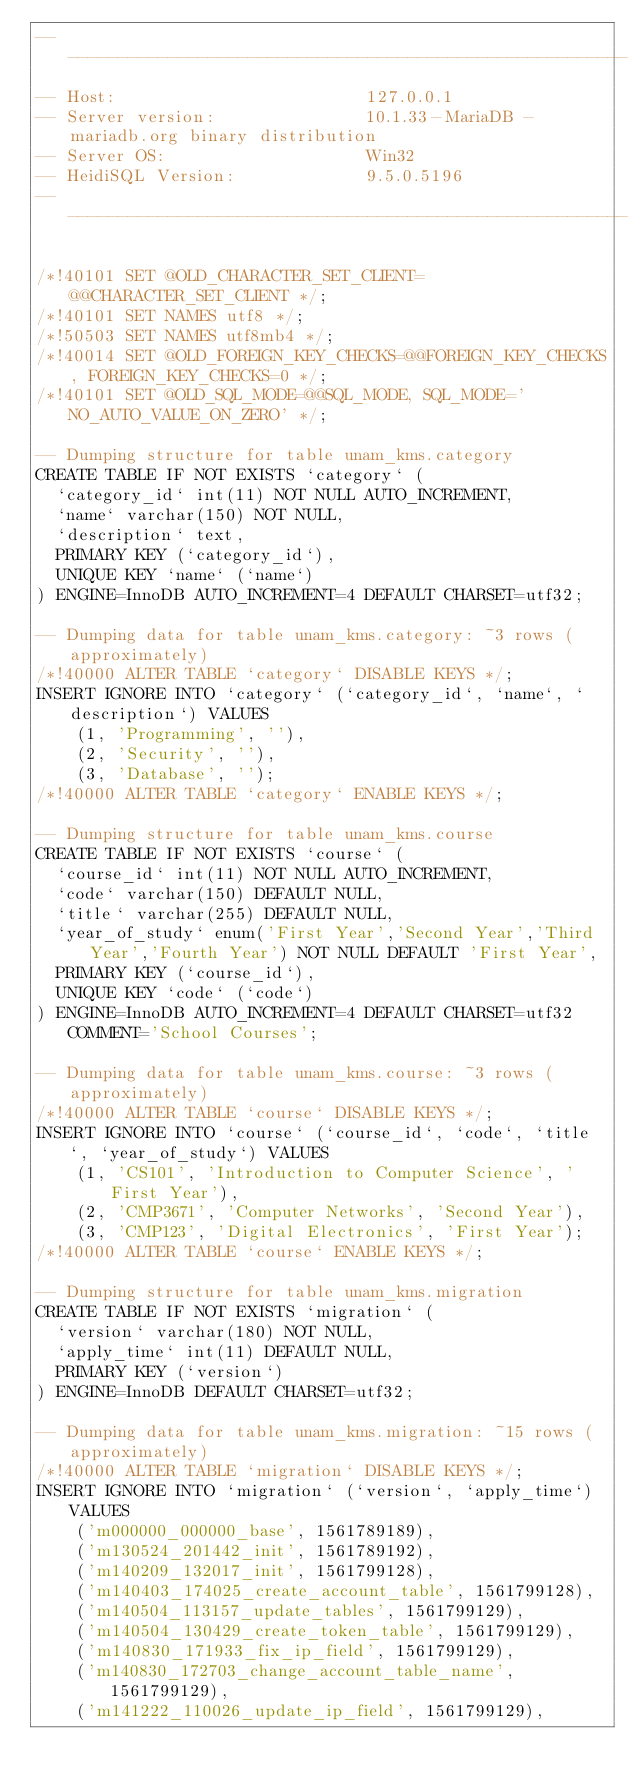Convert code to text. <code><loc_0><loc_0><loc_500><loc_500><_SQL_>-- --------------------------------------------------------
-- Host:                         127.0.0.1
-- Server version:               10.1.33-MariaDB - mariadb.org binary distribution
-- Server OS:                    Win32
-- HeidiSQL Version:             9.5.0.5196
-- --------------------------------------------------------

/*!40101 SET @OLD_CHARACTER_SET_CLIENT=@@CHARACTER_SET_CLIENT */;
/*!40101 SET NAMES utf8 */;
/*!50503 SET NAMES utf8mb4 */;
/*!40014 SET @OLD_FOREIGN_KEY_CHECKS=@@FOREIGN_KEY_CHECKS, FOREIGN_KEY_CHECKS=0 */;
/*!40101 SET @OLD_SQL_MODE=@@SQL_MODE, SQL_MODE='NO_AUTO_VALUE_ON_ZERO' */;

-- Dumping structure for table unam_kms.category
CREATE TABLE IF NOT EXISTS `category` (
  `category_id` int(11) NOT NULL AUTO_INCREMENT,
  `name` varchar(150) NOT NULL,
  `description` text,
  PRIMARY KEY (`category_id`),
  UNIQUE KEY `name` (`name`)
) ENGINE=InnoDB AUTO_INCREMENT=4 DEFAULT CHARSET=utf32;

-- Dumping data for table unam_kms.category: ~3 rows (approximately)
/*!40000 ALTER TABLE `category` DISABLE KEYS */;
INSERT IGNORE INTO `category` (`category_id`, `name`, `description`) VALUES
	(1, 'Programming', ''),
	(2, 'Security', ''),
	(3, 'Database', '');
/*!40000 ALTER TABLE `category` ENABLE KEYS */;

-- Dumping structure for table unam_kms.course
CREATE TABLE IF NOT EXISTS `course` (
  `course_id` int(11) NOT NULL AUTO_INCREMENT,
  `code` varchar(150) DEFAULT NULL,
  `title` varchar(255) DEFAULT NULL,
  `year_of_study` enum('First Year','Second Year','Third Year','Fourth Year') NOT NULL DEFAULT 'First Year',
  PRIMARY KEY (`course_id`),
  UNIQUE KEY `code` (`code`)
) ENGINE=InnoDB AUTO_INCREMENT=4 DEFAULT CHARSET=utf32 COMMENT='School Courses';

-- Dumping data for table unam_kms.course: ~3 rows (approximately)
/*!40000 ALTER TABLE `course` DISABLE KEYS */;
INSERT IGNORE INTO `course` (`course_id`, `code`, `title`, `year_of_study`) VALUES
	(1, 'CS101', 'Introduction to Computer Science', 'First Year'),
	(2, 'CMP3671', 'Computer Networks', 'Second Year'),
	(3, 'CMP123', 'Digital Electronics', 'First Year');
/*!40000 ALTER TABLE `course` ENABLE KEYS */;

-- Dumping structure for table unam_kms.migration
CREATE TABLE IF NOT EXISTS `migration` (
  `version` varchar(180) NOT NULL,
  `apply_time` int(11) DEFAULT NULL,
  PRIMARY KEY (`version`)
) ENGINE=InnoDB DEFAULT CHARSET=utf32;

-- Dumping data for table unam_kms.migration: ~15 rows (approximately)
/*!40000 ALTER TABLE `migration` DISABLE KEYS */;
INSERT IGNORE INTO `migration` (`version`, `apply_time`) VALUES
	('m000000_000000_base', 1561789189),
	('m130524_201442_init', 1561789192),
	('m140209_132017_init', 1561799128),
	('m140403_174025_create_account_table', 1561799128),
	('m140504_113157_update_tables', 1561799129),
	('m140504_130429_create_token_table', 1561799129),
	('m140830_171933_fix_ip_field', 1561799129),
	('m140830_172703_change_account_table_name', 1561799129),
	('m141222_110026_update_ip_field', 1561799129),</code> 